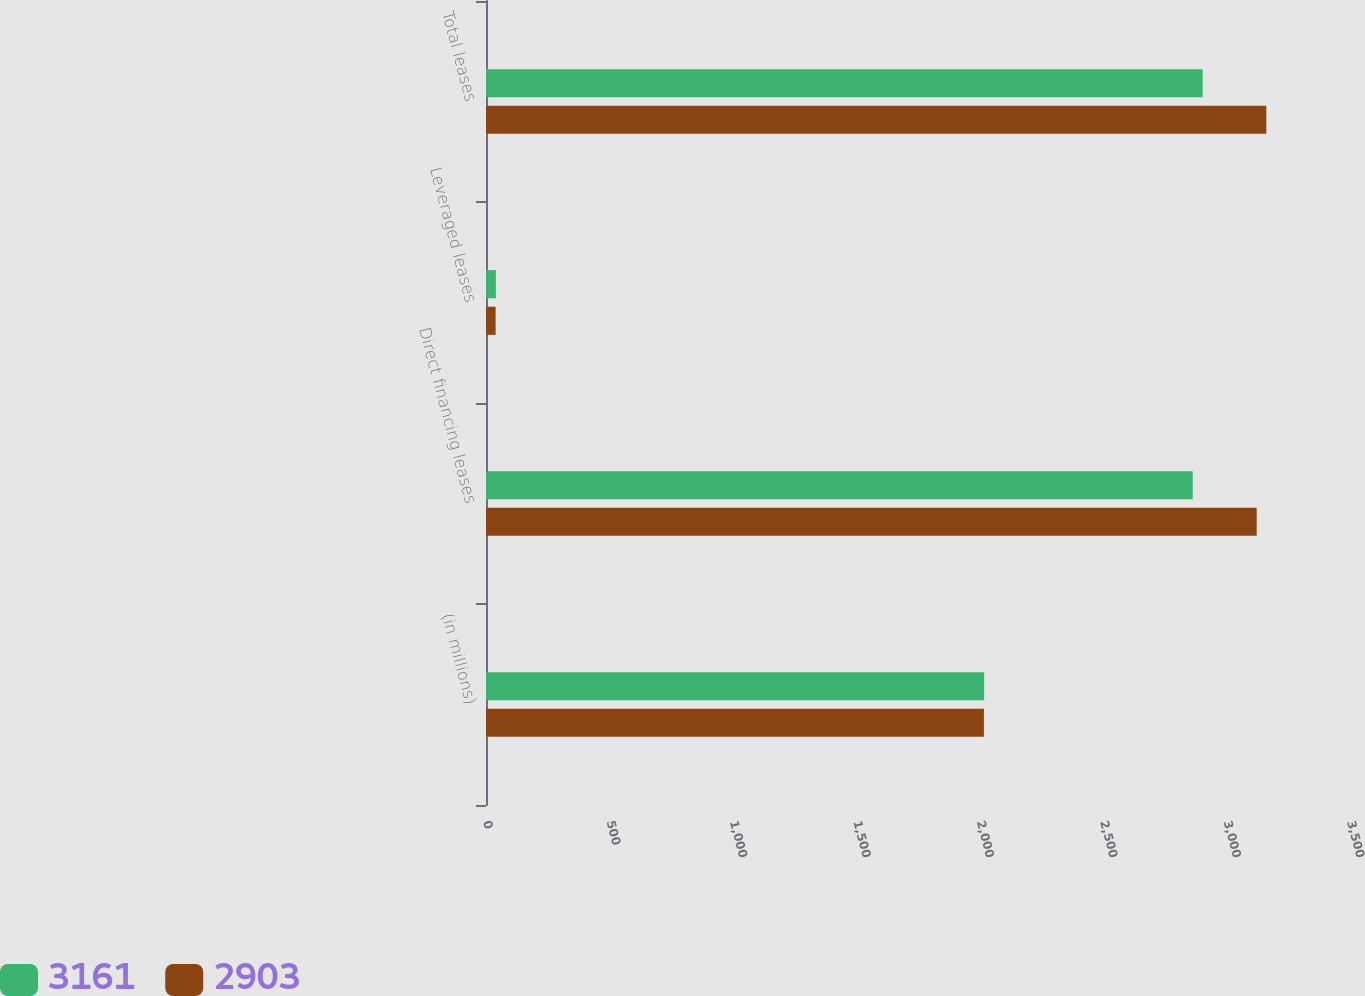Convert chart. <chart><loc_0><loc_0><loc_500><loc_500><stacked_bar_chart><ecel><fcel>(in millions)<fcel>Direct financing leases<fcel>Leveraged leases<fcel>Total leases<nl><fcel>3161<fcel>2018<fcel>2863<fcel>40<fcel>2903<nl><fcel>2903<fcel>2017<fcel>3122<fcel>39<fcel>3161<nl></chart> 